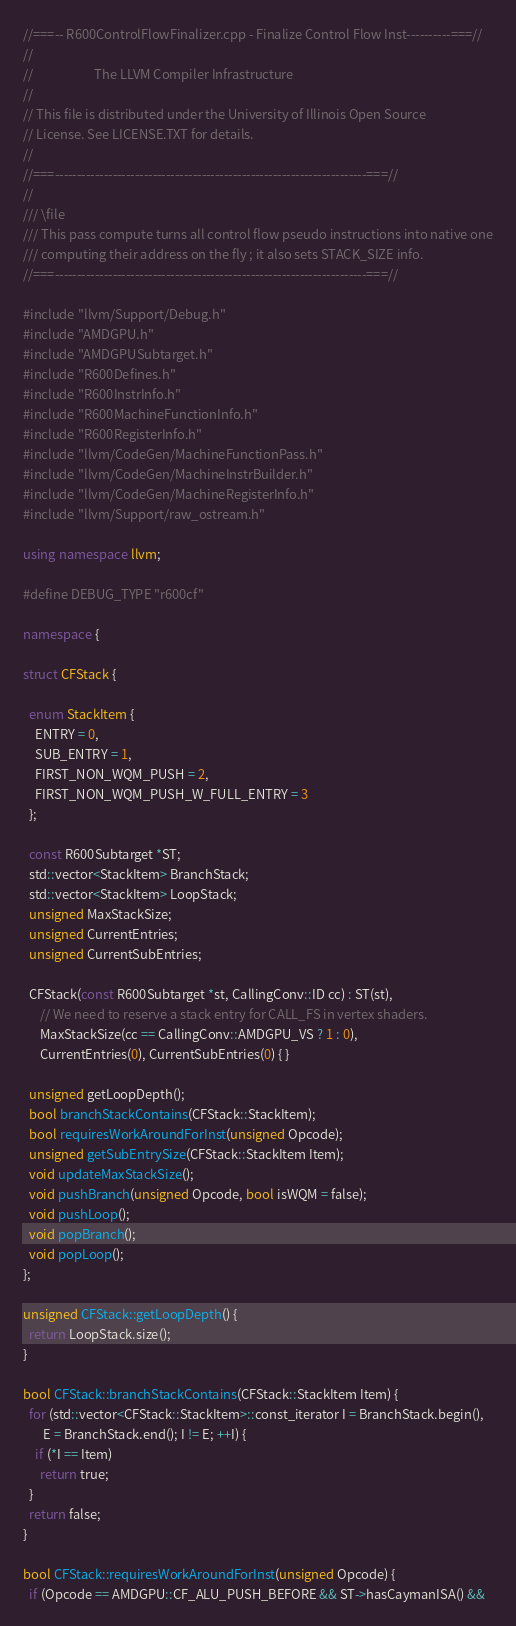<code> <loc_0><loc_0><loc_500><loc_500><_C++_>//===-- R600ControlFlowFinalizer.cpp - Finalize Control Flow Inst----------===//
//
//                     The LLVM Compiler Infrastructure
//
// This file is distributed under the University of Illinois Open Source
// License. See LICENSE.TXT for details.
//
//===----------------------------------------------------------------------===//
//
/// \file
/// This pass compute turns all control flow pseudo instructions into native one
/// computing their address on the fly ; it also sets STACK_SIZE info.
//===----------------------------------------------------------------------===//

#include "llvm/Support/Debug.h"
#include "AMDGPU.h"
#include "AMDGPUSubtarget.h"
#include "R600Defines.h"
#include "R600InstrInfo.h"
#include "R600MachineFunctionInfo.h"
#include "R600RegisterInfo.h"
#include "llvm/CodeGen/MachineFunctionPass.h"
#include "llvm/CodeGen/MachineInstrBuilder.h"
#include "llvm/CodeGen/MachineRegisterInfo.h"
#include "llvm/Support/raw_ostream.h"

using namespace llvm;

#define DEBUG_TYPE "r600cf"

namespace {

struct CFStack {

  enum StackItem {
    ENTRY = 0,
    SUB_ENTRY = 1,
    FIRST_NON_WQM_PUSH = 2,
    FIRST_NON_WQM_PUSH_W_FULL_ENTRY = 3
  };

  const R600Subtarget *ST;
  std::vector<StackItem> BranchStack;
  std::vector<StackItem> LoopStack;
  unsigned MaxStackSize;
  unsigned CurrentEntries;
  unsigned CurrentSubEntries;

  CFStack(const R600Subtarget *st, CallingConv::ID cc) : ST(st),
      // We need to reserve a stack entry for CALL_FS in vertex shaders.
      MaxStackSize(cc == CallingConv::AMDGPU_VS ? 1 : 0),
      CurrentEntries(0), CurrentSubEntries(0) { }

  unsigned getLoopDepth();
  bool branchStackContains(CFStack::StackItem);
  bool requiresWorkAroundForInst(unsigned Opcode);
  unsigned getSubEntrySize(CFStack::StackItem Item);
  void updateMaxStackSize();
  void pushBranch(unsigned Opcode, bool isWQM = false);
  void pushLoop();
  void popBranch();
  void popLoop();
};

unsigned CFStack::getLoopDepth() {
  return LoopStack.size();
}

bool CFStack::branchStackContains(CFStack::StackItem Item) {
  for (std::vector<CFStack::StackItem>::const_iterator I = BranchStack.begin(),
       E = BranchStack.end(); I != E; ++I) {
    if (*I == Item)
      return true;
  }
  return false;
}

bool CFStack::requiresWorkAroundForInst(unsigned Opcode) {
  if (Opcode == AMDGPU::CF_ALU_PUSH_BEFORE && ST->hasCaymanISA() &&</code> 